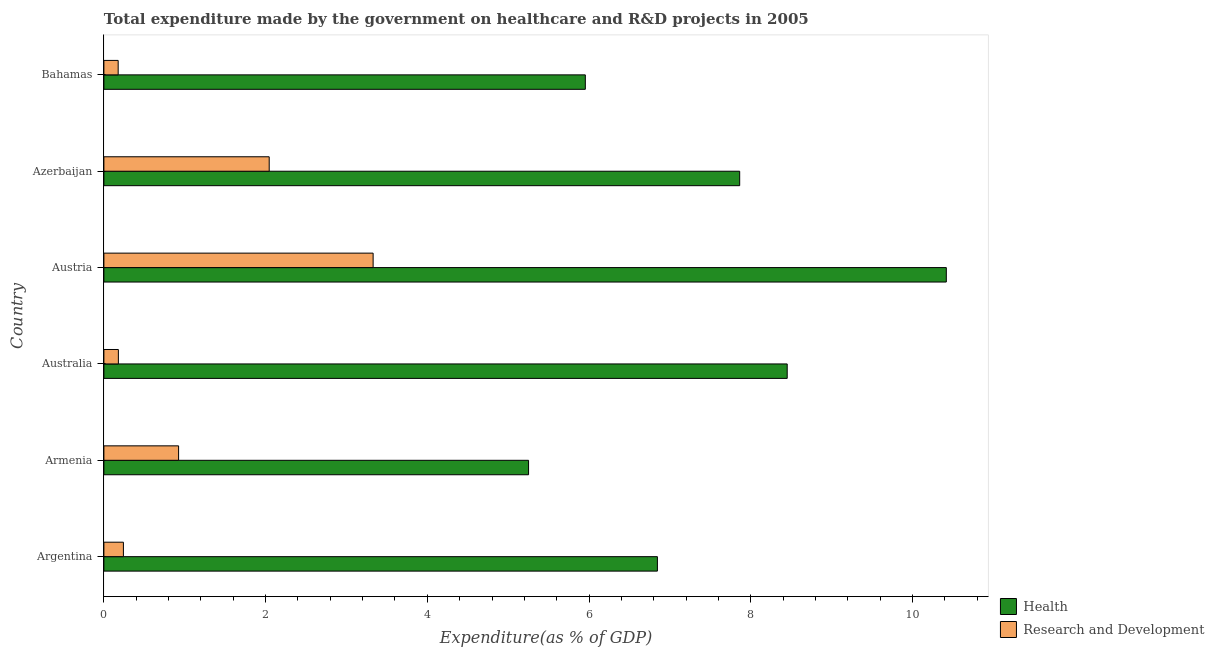How many different coloured bars are there?
Your answer should be very brief. 2. What is the expenditure in r&d in Argentina?
Offer a terse response. 0.24. Across all countries, what is the maximum expenditure in healthcare?
Ensure brevity in your answer.  10.42. Across all countries, what is the minimum expenditure in healthcare?
Offer a terse response. 5.25. In which country was the expenditure in r&d maximum?
Your answer should be very brief. Austria. In which country was the expenditure in healthcare minimum?
Keep it short and to the point. Armenia. What is the total expenditure in healthcare in the graph?
Your answer should be compact. 44.78. What is the difference between the expenditure in healthcare in Australia and that in Bahamas?
Make the answer very short. 2.5. What is the difference between the expenditure in healthcare in Austria and the expenditure in r&d in Bahamas?
Make the answer very short. 10.24. What is the average expenditure in healthcare per country?
Your response must be concise. 7.46. What is the difference between the expenditure in r&d and expenditure in healthcare in Australia?
Provide a short and direct response. -8.27. What is the ratio of the expenditure in healthcare in Argentina to that in Armenia?
Offer a terse response. 1.3. Is the difference between the expenditure in healthcare in Austria and Azerbaijan greater than the difference between the expenditure in r&d in Austria and Azerbaijan?
Your answer should be very brief. Yes. What is the difference between the highest and the second highest expenditure in healthcare?
Your answer should be very brief. 1.97. What is the difference between the highest and the lowest expenditure in healthcare?
Your response must be concise. 5.17. What does the 1st bar from the top in Australia represents?
Offer a very short reply. Research and Development. What does the 2nd bar from the bottom in Argentina represents?
Offer a very short reply. Research and Development. How many bars are there?
Ensure brevity in your answer.  12. Are all the bars in the graph horizontal?
Provide a short and direct response. Yes. What is the difference between two consecutive major ticks on the X-axis?
Your answer should be very brief. 2. Are the values on the major ticks of X-axis written in scientific E-notation?
Keep it short and to the point. No. Does the graph contain any zero values?
Give a very brief answer. No. Does the graph contain grids?
Offer a very short reply. No. Where does the legend appear in the graph?
Your answer should be very brief. Bottom right. How many legend labels are there?
Ensure brevity in your answer.  2. What is the title of the graph?
Offer a terse response. Total expenditure made by the government on healthcare and R&D projects in 2005. Does "GDP" appear as one of the legend labels in the graph?
Offer a terse response. No. What is the label or title of the X-axis?
Offer a terse response. Expenditure(as % of GDP). What is the Expenditure(as % of GDP) of Health in Argentina?
Keep it short and to the point. 6.85. What is the Expenditure(as % of GDP) of Research and Development in Argentina?
Your answer should be compact. 0.24. What is the Expenditure(as % of GDP) of Health in Armenia?
Give a very brief answer. 5.25. What is the Expenditure(as % of GDP) of Research and Development in Armenia?
Ensure brevity in your answer.  0.92. What is the Expenditure(as % of GDP) in Health in Australia?
Your response must be concise. 8.45. What is the Expenditure(as % of GDP) of Research and Development in Australia?
Provide a short and direct response. 0.18. What is the Expenditure(as % of GDP) of Health in Austria?
Offer a terse response. 10.42. What is the Expenditure(as % of GDP) in Research and Development in Austria?
Keep it short and to the point. 3.33. What is the Expenditure(as % of GDP) of Health in Azerbaijan?
Offer a very short reply. 7.86. What is the Expenditure(as % of GDP) in Research and Development in Azerbaijan?
Offer a terse response. 2.04. What is the Expenditure(as % of GDP) of Health in Bahamas?
Your answer should be compact. 5.95. What is the Expenditure(as % of GDP) in Research and Development in Bahamas?
Offer a very short reply. 0.18. Across all countries, what is the maximum Expenditure(as % of GDP) in Health?
Give a very brief answer. 10.42. Across all countries, what is the maximum Expenditure(as % of GDP) of Research and Development?
Offer a very short reply. 3.33. Across all countries, what is the minimum Expenditure(as % of GDP) of Health?
Provide a short and direct response. 5.25. Across all countries, what is the minimum Expenditure(as % of GDP) in Research and Development?
Offer a very short reply. 0.18. What is the total Expenditure(as % of GDP) in Health in the graph?
Offer a terse response. 44.78. What is the total Expenditure(as % of GDP) of Research and Development in the graph?
Give a very brief answer. 6.9. What is the difference between the Expenditure(as % of GDP) of Health in Argentina and that in Armenia?
Provide a succinct answer. 1.59. What is the difference between the Expenditure(as % of GDP) in Research and Development in Argentina and that in Armenia?
Keep it short and to the point. -0.68. What is the difference between the Expenditure(as % of GDP) in Health in Argentina and that in Australia?
Give a very brief answer. -1.61. What is the difference between the Expenditure(as % of GDP) of Research and Development in Argentina and that in Australia?
Give a very brief answer. 0.06. What is the difference between the Expenditure(as % of GDP) in Health in Argentina and that in Austria?
Offer a terse response. -3.57. What is the difference between the Expenditure(as % of GDP) in Research and Development in Argentina and that in Austria?
Provide a succinct answer. -3.09. What is the difference between the Expenditure(as % of GDP) of Health in Argentina and that in Azerbaijan?
Your response must be concise. -1.02. What is the difference between the Expenditure(as % of GDP) in Research and Development in Argentina and that in Azerbaijan?
Your answer should be very brief. -1.8. What is the difference between the Expenditure(as % of GDP) in Health in Argentina and that in Bahamas?
Ensure brevity in your answer.  0.89. What is the difference between the Expenditure(as % of GDP) of Research and Development in Argentina and that in Bahamas?
Offer a terse response. 0.06. What is the difference between the Expenditure(as % of GDP) in Health in Armenia and that in Australia?
Offer a very short reply. -3.2. What is the difference between the Expenditure(as % of GDP) of Research and Development in Armenia and that in Australia?
Offer a terse response. 0.74. What is the difference between the Expenditure(as % of GDP) of Health in Armenia and that in Austria?
Your answer should be compact. -5.17. What is the difference between the Expenditure(as % of GDP) in Research and Development in Armenia and that in Austria?
Provide a succinct answer. -2.41. What is the difference between the Expenditure(as % of GDP) in Health in Armenia and that in Azerbaijan?
Keep it short and to the point. -2.61. What is the difference between the Expenditure(as % of GDP) in Research and Development in Armenia and that in Azerbaijan?
Offer a terse response. -1.12. What is the difference between the Expenditure(as % of GDP) in Health in Armenia and that in Bahamas?
Offer a terse response. -0.7. What is the difference between the Expenditure(as % of GDP) in Research and Development in Armenia and that in Bahamas?
Ensure brevity in your answer.  0.75. What is the difference between the Expenditure(as % of GDP) in Health in Australia and that in Austria?
Keep it short and to the point. -1.97. What is the difference between the Expenditure(as % of GDP) in Research and Development in Australia and that in Austria?
Your response must be concise. -3.15. What is the difference between the Expenditure(as % of GDP) in Health in Australia and that in Azerbaijan?
Offer a terse response. 0.59. What is the difference between the Expenditure(as % of GDP) of Research and Development in Australia and that in Azerbaijan?
Provide a short and direct response. -1.87. What is the difference between the Expenditure(as % of GDP) of Health in Australia and that in Bahamas?
Make the answer very short. 2.5. What is the difference between the Expenditure(as % of GDP) in Research and Development in Australia and that in Bahamas?
Your response must be concise. 0. What is the difference between the Expenditure(as % of GDP) of Health in Austria and that in Azerbaijan?
Offer a very short reply. 2.56. What is the difference between the Expenditure(as % of GDP) of Research and Development in Austria and that in Azerbaijan?
Keep it short and to the point. 1.29. What is the difference between the Expenditure(as % of GDP) of Health in Austria and that in Bahamas?
Make the answer very short. 4.46. What is the difference between the Expenditure(as % of GDP) of Research and Development in Austria and that in Bahamas?
Your answer should be very brief. 3.15. What is the difference between the Expenditure(as % of GDP) of Health in Azerbaijan and that in Bahamas?
Your answer should be very brief. 1.91. What is the difference between the Expenditure(as % of GDP) of Research and Development in Azerbaijan and that in Bahamas?
Make the answer very short. 1.87. What is the difference between the Expenditure(as % of GDP) of Health in Argentina and the Expenditure(as % of GDP) of Research and Development in Armenia?
Offer a terse response. 5.92. What is the difference between the Expenditure(as % of GDP) of Health in Argentina and the Expenditure(as % of GDP) of Research and Development in Australia?
Offer a very short reply. 6.67. What is the difference between the Expenditure(as % of GDP) of Health in Argentina and the Expenditure(as % of GDP) of Research and Development in Austria?
Give a very brief answer. 3.52. What is the difference between the Expenditure(as % of GDP) in Health in Argentina and the Expenditure(as % of GDP) in Research and Development in Azerbaijan?
Offer a very short reply. 4.8. What is the difference between the Expenditure(as % of GDP) of Health in Argentina and the Expenditure(as % of GDP) of Research and Development in Bahamas?
Keep it short and to the point. 6.67. What is the difference between the Expenditure(as % of GDP) of Health in Armenia and the Expenditure(as % of GDP) of Research and Development in Australia?
Your response must be concise. 5.07. What is the difference between the Expenditure(as % of GDP) of Health in Armenia and the Expenditure(as % of GDP) of Research and Development in Austria?
Make the answer very short. 1.92. What is the difference between the Expenditure(as % of GDP) in Health in Armenia and the Expenditure(as % of GDP) in Research and Development in Azerbaijan?
Offer a very short reply. 3.21. What is the difference between the Expenditure(as % of GDP) in Health in Armenia and the Expenditure(as % of GDP) in Research and Development in Bahamas?
Give a very brief answer. 5.08. What is the difference between the Expenditure(as % of GDP) of Health in Australia and the Expenditure(as % of GDP) of Research and Development in Austria?
Offer a terse response. 5.12. What is the difference between the Expenditure(as % of GDP) in Health in Australia and the Expenditure(as % of GDP) in Research and Development in Azerbaijan?
Offer a terse response. 6.41. What is the difference between the Expenditure(as % of GDP) in Health in Australia and the Expenditure(as % of GDP) in Research and Development in Bahamas?
Provide a short and direct response. 8.27. What is the difference between the Expenditure(as % of GDP) in Health in Austria and the Expenditure(as % of GDP) in Research and Development in Azerbaijan?
Offer a terse response. 8.37. What is the difference between the Expenditure(as % of GDP) in Health in Austria and the Expenditure(as % of GDP) in Research and Development in Bahamas?
Offer a very short reply. 10.24. What is the difference between the Expenditure(as % of GDP) in Health in Azerbaijan and the Expenditure(as % of GDP) in Research and Development in Bahamas?
Give a very brief answer. 7.69. What is the average Expenditure(as % of GDP) in Health per country?
Give a very brief answer. 7.46. What is the average Expenditure(as % of GDP) in Research and Development per country?
Offer a terse response. 1.15. What is the difference between the Expenditure(as % of GDP) in Health and Expenditure(as % of GDP) in Research and Development in Argentina?
Your answer should be very brief. 6.6. What is the difference between the Expenditure(as % of GDP) in Health and Expenditure(as % of GDP) in Research and Development in Armenia?
Make the answer very short. 4.33. What is the difference between the Expenditure(as % of GDP) in Health and Expenditure(as % of GDP) in Research and Development in Australia?
Offer a very short reply. 8.27. What is the difference between the Expenditure(as % of GDP) of Health and Expenditure(as % of GDP) of Research and Development in Austria?
Provide a short and direct response. 7.09. What is the difference between the Expenditure(as % of GDP) of Health and Expenditure(as % of GDP) of Research and Development in Azerbaijan?
Provide a short and direct response. 5.82. What is the difference between the Expenditure(as % of GDP) in Health and Expenditure(as % of GDP) in Research and Development in Bahamas?
Provide a short and direct response. 5.78. What is the ratio of the Expenditure(as % of GDP) in Health in Argentina to that in Armenia?
Ensure brevity in your answer.  1.3. What is the ratio of the Expenditure(as % of GDP) in Research and Development in Argentina to that in Armenia?
Provide a succinct answer. 0.26. What is the ratio of the Expenditure(as % of GDP) in Health in Argentina to that in Australia?
Offer a terse response. 0.81. What is the ratio of the Expenditure(as % of GDP) of Research and Development in Argentina to that in Australia?
Offer a very short reply. 1.35. What is the ratio of the Expenditure(as % of GDP) of Health in Argentina to that in Austria?
Your answer should be compact. 0.66. What is the ratio of the Expenditure(as % of GDP) in Research and Development in Argentina to that in Austria?
Provide a short and direct response. 0.07. What is the ratio of the Expenditure(as % of GDP) of Health in Argentina to that in Azerbaijan?
Give a very brief answer. 0.87. What is the ratio of the Expenditure(as % of GDP) in Research and Development in Argentina to that in Azerbaijan?
Your answer should be compact. 0.12. What is the ratio of the Expenditure(as % of GDP) of Health in Argentina to that in Bahamas?
Offer a terse response. 1.15. What is the ratio of the Expenditure(as % of GDP) in Research and Development in Argentina to that in Bahamas?
Offer a very short reply. 1.37. What is the ratio of the Expenditure(as % of GDP) in Health in Armenia to that in Australia?
Offer a terse response. 0.62. What is the ratio of the Expenditure(as % of GDP) of Research and Development in Armenia to that in Australia?
Provide a short and direct response. 5.16. What is the ratio of the Expenditure(as % of GDP) in Health in Armenia to that in Austria?
Offer a very short reply. 0.5. What is the ratio of the Expenditure(as % of GDP) of Research and Development in Armenia to that in Austria?
Ensure brevity in your answer.  0.28. What is the ratio of the Expenditure(as % of GDP) in Health in Armenia to that in Azerbaijan?
Provide a succinct answer. 0.67. What is the ratio of the Expenditure(as % of GDP) in Research and Development in Armenia to that in Azerbaijan?
Provide a succinct answer. 0.45. What is the ratio of the Expenditure(as % of GDP) in Health in Armenia to that in Bahamas?
Provide a short and direct response. 0.88. What is the ratio of the Expenditure(as % of GDP) of Research and Development in Armenia to that in Bahamas?
Provide a succinct answer. 5.23. What is the ratio of the Expenditure(as % of GDP) in Health in Australia to that in Austria?
Make the answer very short. 0.81. What is the ratio of the Expenditure(as % of GDP) of Research and Development in Australia to that in Austria?
Make the answer very short. 0.05. What is the ratio of the Expenditure(as % of GDP) in Health in Australia to that in Azerbaijan?
Provide a succinct answer. 1.07. What is the ratio of the Expenditure(as % of GDP) of Research and Development in Australia to that in Azerbaijan?
Your answer should be compact. 0.09. What is the ratio of the Expenditure(as % of GDP) in Health in Australia to that in Bahamas?
Offer a terse response. 1.42. What is the ratio of the Expenditure(as % of GDP) of Research and Development in Australia to that in Bahamas?
Give a very brief answer. 1.01. What is the ratio of the Expenditure(as % of GDP) of Health in Austria to that in Azerbaijan?
Provide a short and direct response. 1.32. What is the ratio of the Expenditure(as % of GDP) in Research and Development in Austria to that in Azerbaijan?
Your answer should be compact. 1.63. What is the ratio of the Expenditure(as % of GDP) in Health in Austria to that in Bahamas?
Your answer should be very brief. 1.75. What is the ratio of the Expenditure(as % of GDP) in Research and Development in Austria to that in Bahamas?
Offer a terse response. 18.86. What is the ratio of the Expenditure(as % of GDP) of Health in Azerbaijan to that in Bahamas?
Offer a terse response. 1.32. What is the ratio of the Expenditure(as % of GDP) in Research and Development in Azerbaijan to that in Bahamas?
Provide a short and direct response. 11.58. What is the difference between the highest and the second highest Expenditure(as % of GDP) of Health?
Make the answer very short. 1.97. What is the difference between the highest and the second highest Expenditure(as % of GDP) of Research and Development?
Your answer should be compact. 1.29. What is the difference between the highest and the lowest Expenditure(as % of GDP) in Health?
Make the answer very short. 5.17. What is the difference between the highest and the lowest Expenditure(as % of GDP) in Research and Development?
Provide a short and direct response. 3.15. 